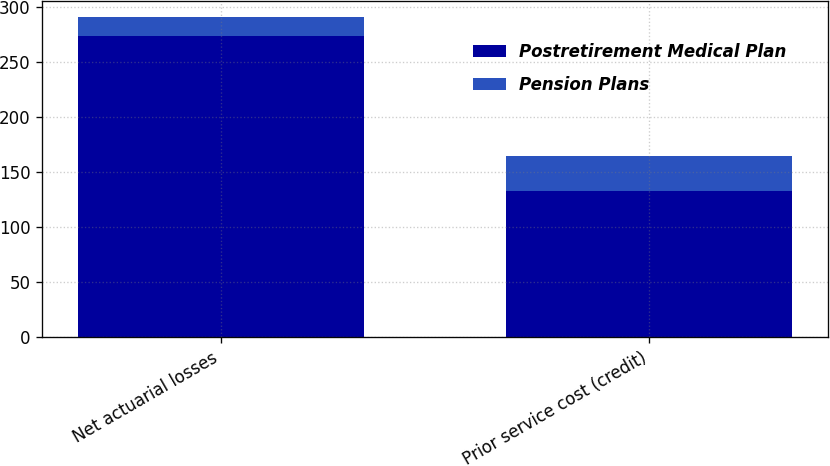Convert chart. <chart><loc_0><loc_0><loc_500><loc_500><stacked_bar_chart><ecel><fcel>Net actuarial losses<fcel>Prior service cost (credit)<nl><fcel>Postretirement Medical Plan<fcel>274<fcel>133<nl><fcel>Pension Plans<fcel>17<fcel>32<nl></chart> 